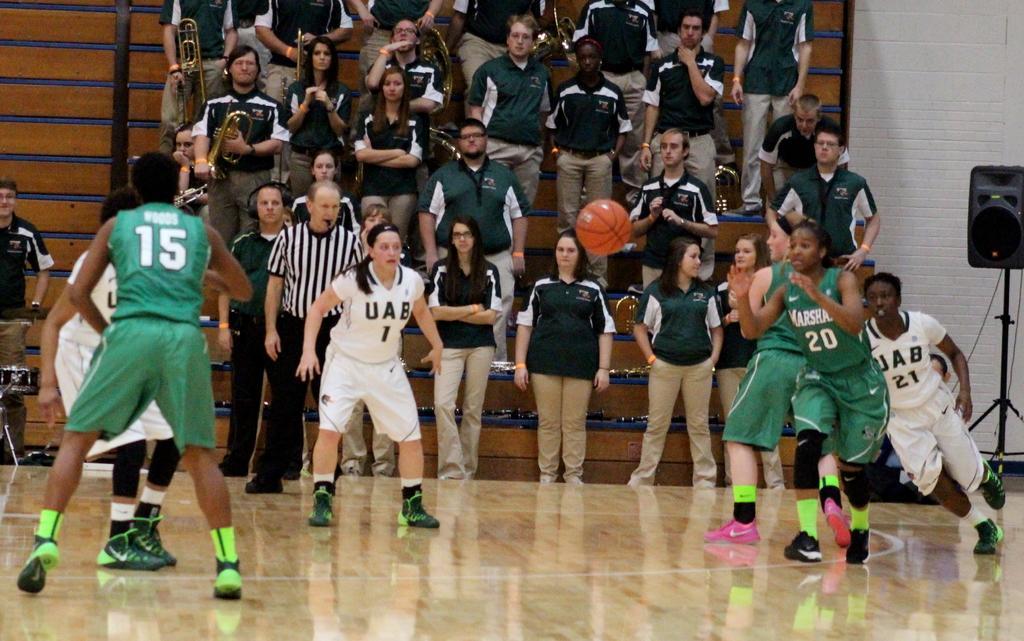Could you give a brief overview of what you see in this image? In this picture I can observe women playing basketball in the court. I can observe green and white color jerseys. In the middle of the picture there is a basketball. In the background there are some people standing and watching the game. 